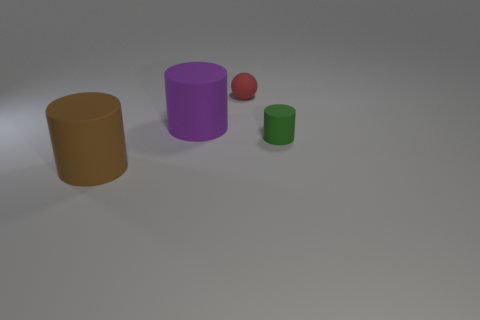Subtract all purple cylinders. Subtract all cyan blocks. How many cylinders are left? 2 Add 2 tiny red objects. How many objects exist? 6 Subtract all cylinders. How many objects are left? 1 Add 3 matte things. How many matte things exist? 7 Subtract 0 brown blocks. How many objects are left? 4 Subtract all big rubber cylinders. Subtract all big cyan cylinders. How many objects are left? 2 Add 2 red rubber things. How many red rubber things are left? 3 